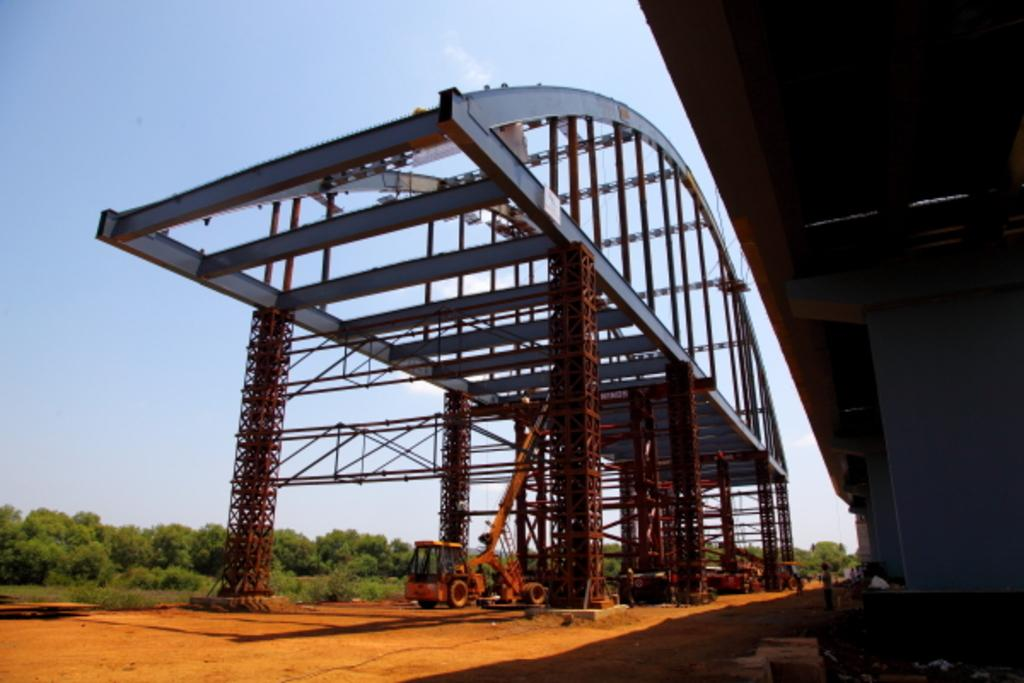What types of vehicles can be seen in the image? There are vehicles in the image, but the specific types cannot be determined from the provided facts. What structures are present in the image? There are pillars and a bridge in the image. What type of vegetation is visible in the image? There are trees in the image. What can be seen in the background of the image? The sky is visible in the background of the image. What type of hat is the fowl wearing in the image? There is no fowl or hat present in the image. Can you describe the color of the moon in the image? There is no moon present in the image. 